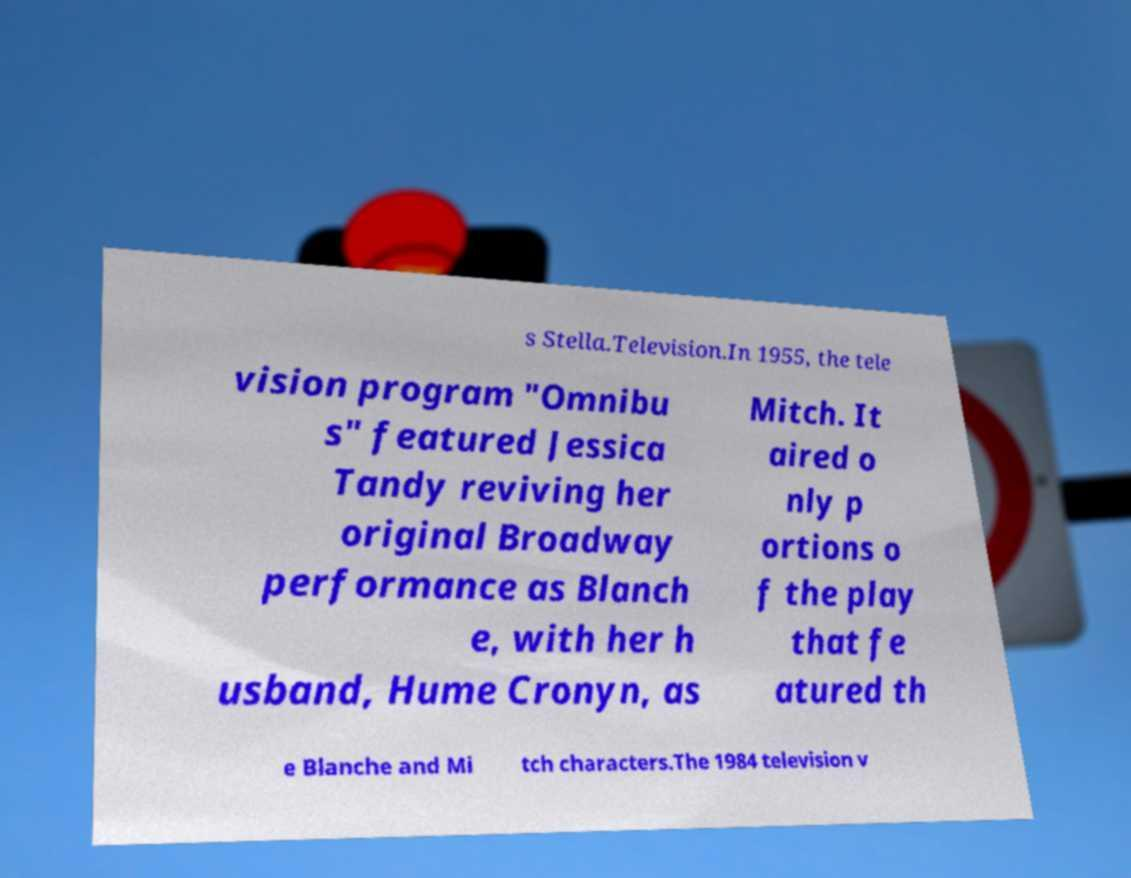Could you extract and type out the text from this image? s Stella.Television.In 1955, the tele vision program "Omnibu s" featured Jessica Tandy reviving her original Broadway performance as Blanch e, with her h usband, Hume Cronyn, as Mitch. It aired o nly p ortions o f the play that fe atured th e Blanche and Mi tch characters.The 1984 television v 